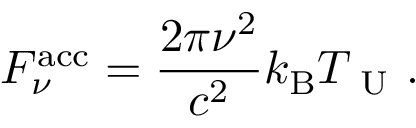<formula> <loc_0><loc_0><loc_500><loc_500>F _ { \nu } ^ { a c c } = \frac { 2 \pi \nu ^ { 2 } } { c ^ { 2 } } k _ { B } T _ { U } .</formula> 